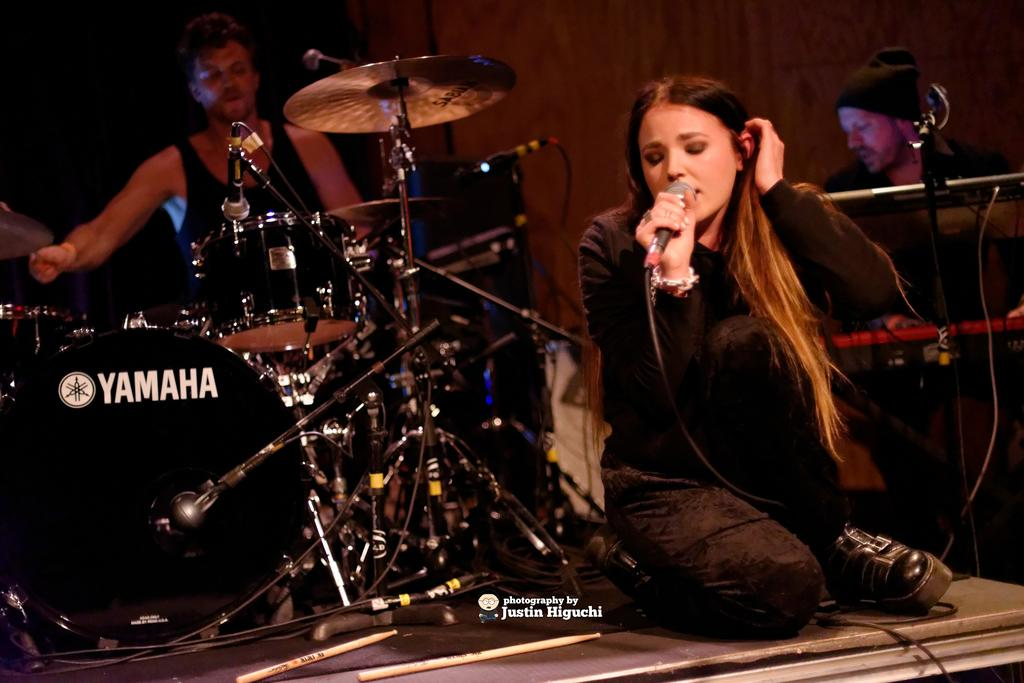Who is the main subject in the image? There is a girl in the image. What is the girl wearing? The girl is wearing a black shirt and jeans. What is the girl holding in the image? The girl is holding a microphone. Where is the girl sitting in the image? The girl is sitting on the floor. What else can be seen in the image besides the girl? There are musical instruments in the image. What brand are the musical instruments? The musical instruments have "Yamaha" written on them. What type of hall is visible in the image? There is no hall present in the image. What boundary is the girl sitting near in the image? The girl is sitting on the floor, and there is no boundary visible in the image. 